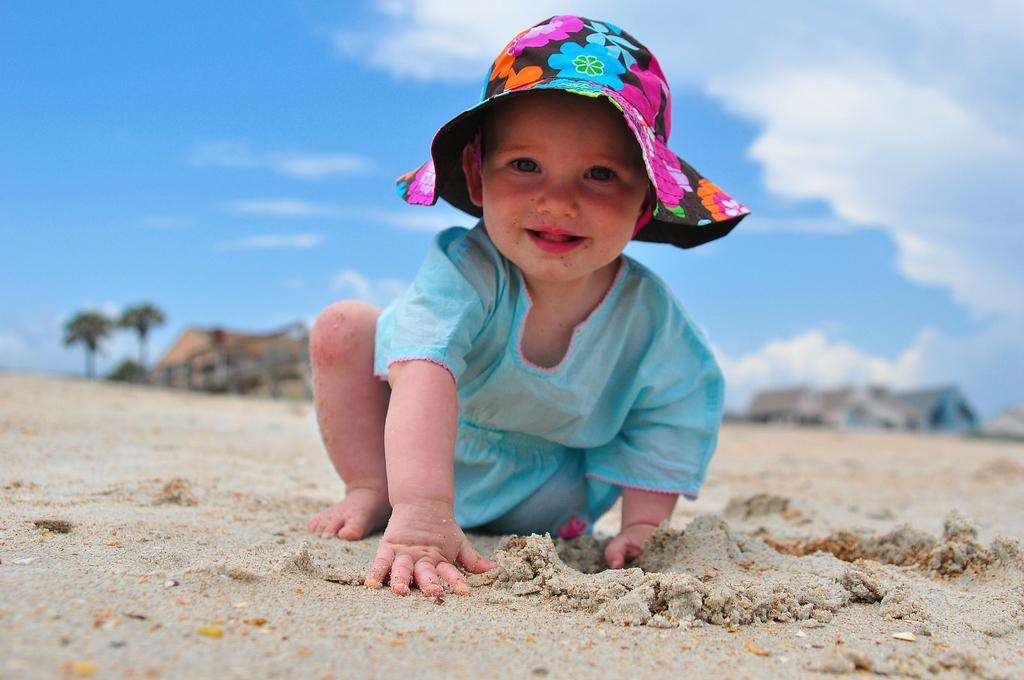In one or two sentences, can you explain what this image depicts? Here a little cute baby is on the sand, she wore a blue color dress and a colorful hat. 